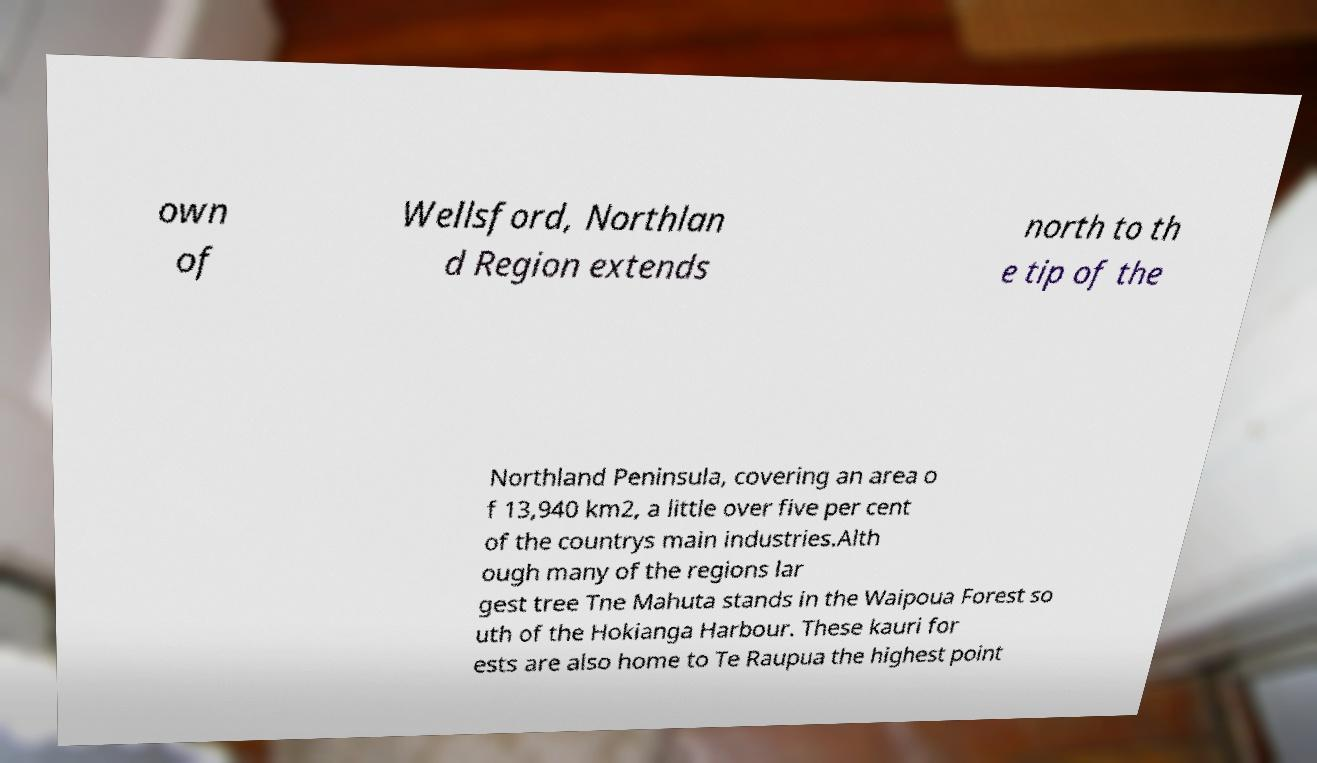Please identify and transcribe the text found in this image. own of Wellsford, Northlan d Region extends north to th e tip of the Northland Peninsula, covering an area o f 13,940 km2, a little over five per cent of the countrys main industries.Alth ough many of the regions lar gest tree Tne Mahuta stands in the Waipoua Forest so uth of the Hokianga Harbour. These kauri for ests are also home to Te Raupua the highest point 